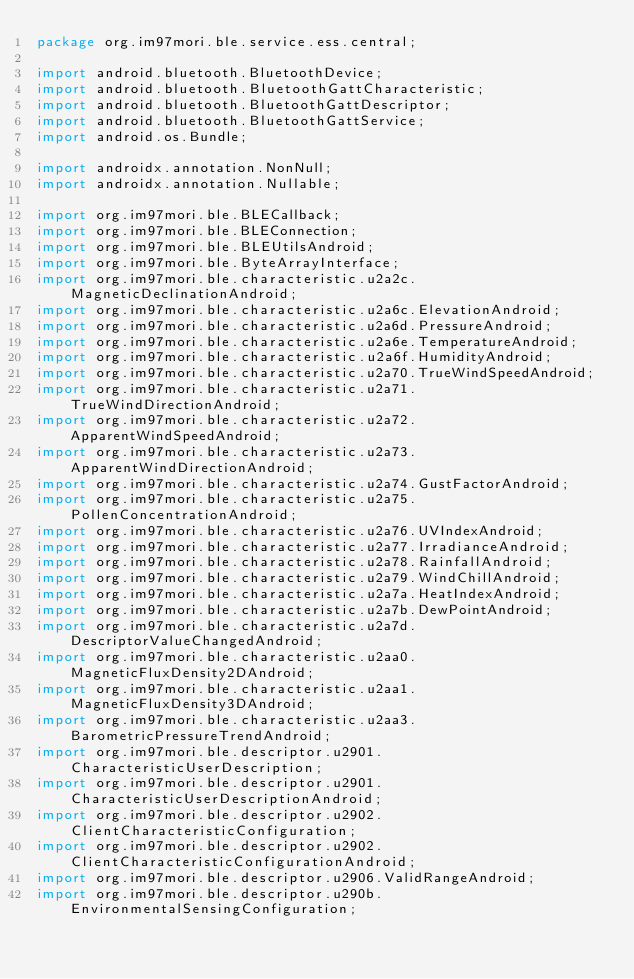Convert code to text. <code><loc_0><loc_0><loc_500><loc_500><_Java_>package org.im97mori.ble.service.ess.central;

import android.bluetooth.BluetoothDevice;
import android.bluetooth.BluetoothGattCharacteristic;
import android.bluetooth.BluetoothGattDescriptor;
import android.bluetooth.BluetoothGattService;
import android.os.Bundle;

import androidx.annotation.NonNull;
import androidx.annotation.Nullable;

import org.im97mori.ble.BLECallback;
import org.im97mori.ble.BLEConnection;
import org.im97mori.ble.BLEUtilsAndroid;
import org.im97mori.ble.ByteArrayInterface;
import org.im97mori.ble.characteristic.u2a2c.MagneticDeclinationAndroid;
import org.im97mori.ble.characteristic.u2a6c.ElevationAndroid;
import org.im97mori.ble.characteristic.u2a6d.PressureAndroid;
import org.im97mori.ble.characteristic.u2a6e.TemperatureAndroid;
import org.im97mori.ble.characteristic.u2a6f.HumidityAndroid;
import org.im97mori.ble.characteristic.u2a70.TrueWindSpeedAndroid;
import org.im97mori.ble.characteristic.u2a71.TrueWindDirectionAndroid;
import org.im97mori.ble.characteristic.u2a72.ApparentWindSpeedAndroid;
import org.im97mori.ble.characteristic.u2a73.ApparentWindDirectionAndroid;
import org.im97mori.ble.characteristic.u2a74.GustFactorAndroid;
import org.im97mori.ble.characteristic.u2a75.PollenConcentrationAndroid;
import org.im97mori.ble.characteristic.u2a76.UVIndexAndroid;
import org.im97mori.ble.characteristic.u2a77.IrradianceAndroid;
import org.im97mori.ble.characteristic.u2a78.RainfallAndroid;
import org.im97mori.ble.characteristic.u2a79.WindChillAndroid;
import org.im97mori.ble.characteristic.u2a7a.HeatIndexAndroid;
import org.im97mori.ble.characteristic.u2a7b.DewPointAndroid;
import org.im97mori.ble.characteristic.u2a7d.DescriptorValueChangedAndroid;
import org.im97mori.ble.characteristic.u2aa0.MagneticFluxDensity2DAndroid;
import org.im97mori.ble.characteristic.u2aa1.MagneticFluxDensity3DAndroid;
import org.im97mori.ble.characteristic.u2aa3.BarometricPressureTrendAndroid;
import org.im97mori.ble.descriptor.u2901.CharacteristicUserDescription;
import org.im97mori.ble.descriptor.u2901.CharacteristicUserDescriptionAndroid;
import org.im97mori.ble.descriptor.u2902.ClientCharacteristicConfiguration;
import org.im97mori.ble.descriptor.u2902.ClientCharacteristicConfigurationAndroid;
import org.im97mori.ble.descriptor.u2906.ValidRangeAndroid;
import org.im97mori.ble.descriptor.u290b.EnvironmentalSensingConfiguration;</code> 